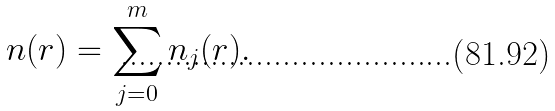<formula> <loc_0><loc_0><loc_500><loc_500>n ( r ) = \sum _ { j = 0 } ^ { m } n _ { j } ( r ) .</formula> 